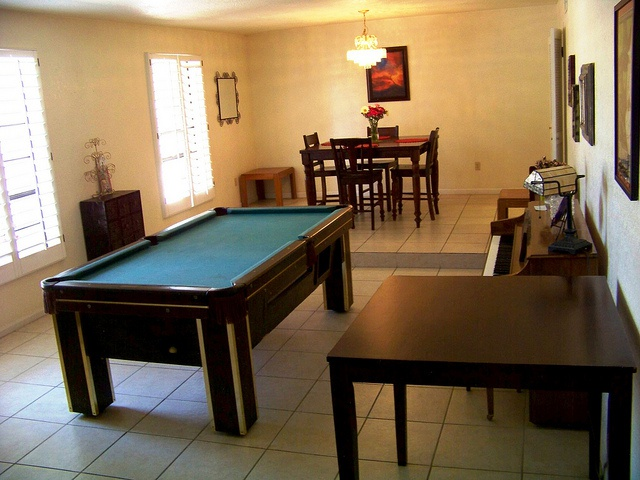Describe the objects in this image and their specific colors. I can see dining table in darkgray, black, maroon, brown, and gray tones, chair in darkgray, black, maroon, and gray tones, chair in darkgray, black, maroon, and olive tones, chair in darkgray, black, maroon, and tan tones, and chair in darkgray, maroon, and olive tones in this image. 